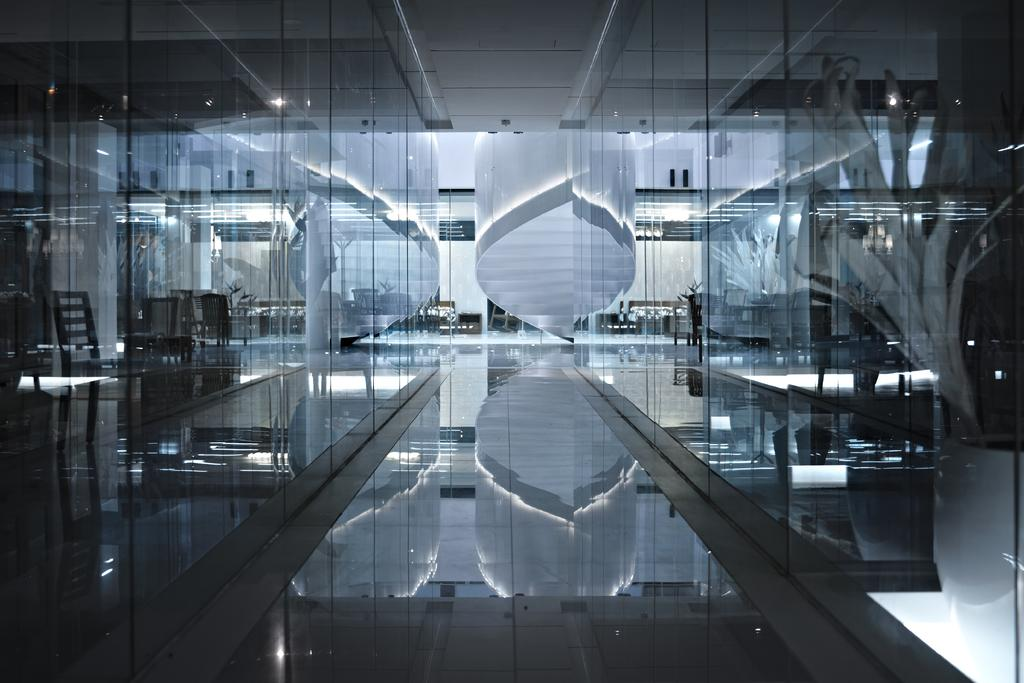What type of location is depicted in the image? The image is of the inside of a building. What type of furniture can be seen in the image? There are chairs in the image. What type of illumination is present in the image? There are lights in the image. What type of architectural feature is present in the image? There are glass doors in the image. What type of surface is visible at the bottom of the image? There is a floor visible at the bottom of the image. What type of cloth is draped over the wheel in the image? There is no wheel or cloth present in the image. 